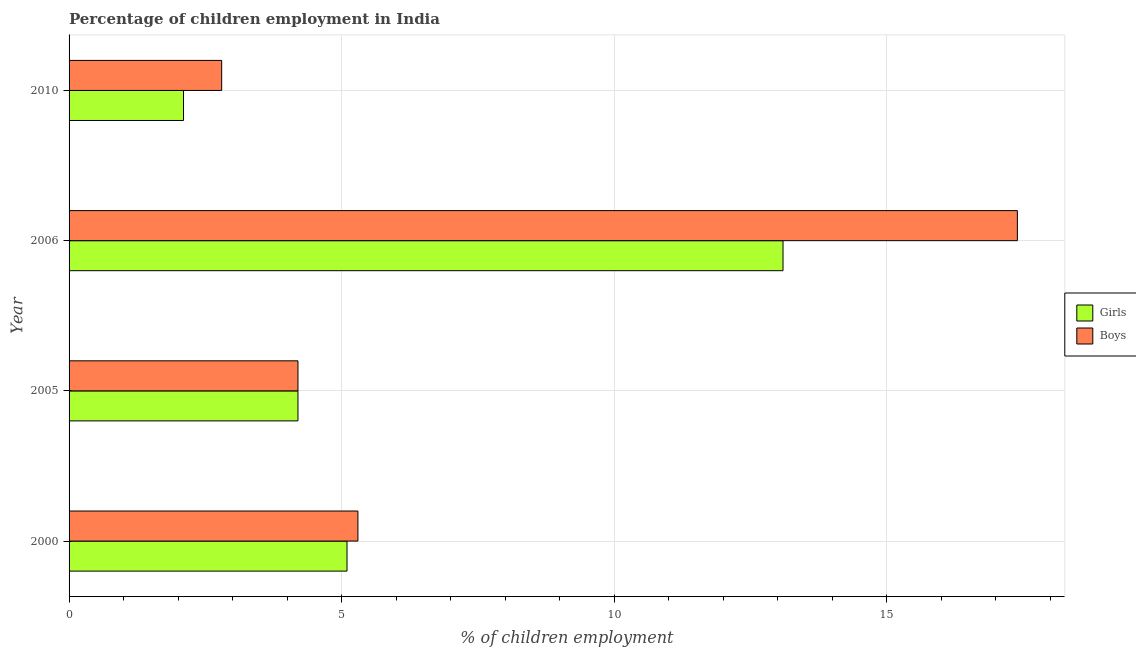How many different coloured bars are there?
Give a very brief answer. 2. How many groups of bars are there?
Offer a very short reply. 4. Are the number of bars per tick equal to the number of legend labels?
Your response must be concise. Yes. Are the number of bars on each tick of the Y-axis equal?
Provide a succinct answer. Yes. What is the label of the 4th group of bars from the top?
Offer a terse response. 2000. In how many cases, is the number of bars for a given year not equal to the number of legend labels?
Your answer should be very brief. 0. In which year was the percentage of employed boys maximum?
Offer a very short reply. 2006. In which year was the percentage of employed girls minimum?
Your response must be concise. 2010. What is the total percentage of employed boys in the graph?
Keep it short and to the point. 29.7. What is the difference between the percentage of employed girls in 2005 and the percentage of employed boys in 2006?
Your answer should be compact. -13.2. What is the average percentage of employed girls per year?
Provide a short and direct response. 6.12. In the year 2000, what is the difference between the percentage of employed boys and percentage of employed girls?
Keep it short and to the point. 0.2. In how many years, is the percentage of employed boys greater than 14 %?
Offer a very short reply. 1. What is the ratio of the percentage of employed boys in 2000 to that in 2010?
Provide a succinct answer. 1.89. What is the difference between the highest and the second highest percentage of employed girls?
Offer a terse response. 8. What is the difference between the highest and the lowest percentage of employed boys?
Offer a terse response. 14.6. In how many years, is the percentage of employed boys greater than the average percentage of employed boys taken over all years?
Offer a very short reply. 1. What does the 1st bar from the top in 2006 represents?
Ensure brevity in your answer.  Boys. What does the 2nd bar from the bottom in 2006 represents?
Keep it short and to the point. Boys. Are the values on the major ticks of X-axis written in scientific E-notation?
Make the answer very short. No. Where does the legend appear in the graph?
Your response must be concise. Center right. What is the title of the graph?
Offer a terse response. Percentage of children employment in India. Does "Investment in Transport" appear as one of the legend labels in the graph?
Keep it short and to the point. No. What is the label or title of the X-axis?
Your answer should be very brief. % of children employment. What is the % of children employment in Girls in 2000?
Keep it short and to the point. 5.1. What is the % of children employment in Boys in 2005?
Your response must be concise. 4.2. What is the % of children employment of Girls in 2006?
Provide a succinct answer. 13.1. What is the % of children employment in Boys in 2006?
Provide a short and direct response. 17.4. What is the % of children employment in Boys in 2010?
Ensure brevity in your answer.  2.8. Across all years, what is the maximum % of children employment of Boys?
Make the answer very short. 17.4. Across all years, what is the minimum % of children employment in Boys?
Ensure brevity in your answer.  2.8. What is the total % of children employment in Boys in the graph?
Your answer should be compact. 29.7. What is the difference between the % of children employment of Girls in 2000 and that in 2005?
Your answer should be compact. 0.9. What is the difference between the % of children employment of Boys in 2000 and that in 2005?
Provide a short and direct response. 1.1. What is the difference between the % of children employment of Girls in 2000 and that in 2010?
Your response must be concise. 3. What is the difference between the % of children employment of Boys in 2000 and that in 2010?
Provide a short and direct response. 2.5. What is the difference between the % of children employment of Boys in 2005 and that in 2010?
Give a very brief answer. 1.4. What is the difference between the % of children employment of Girls in 2006 and that in 2010?
Make the answer very short. 11. What is the difference between the % of children employment in Girls in 2000 and the % of children employment in Boys in 2010?
Offer a very short reply. 2.3. What is the difference between the % of children employment in Girls in 2005 and the % of children employment in Boys in 2006?
Keep it short and to the point. -13.2. What is the average % of children employment in Girls per year?
Ensure brevity in your answer.  6.12. What is the average % of children employment in Boys per year?
Keep it short and to the point. 7.42. In the year 2000, what is the difference between the % of children employment of Girls and % of children employment of Boys?
Make the answer very short. -0.2. In the year 2005, what is the difference between the % of children employment in Girls and % of children employment in Boys?
Your response must be concise. 0. In the year 2010, what is the difference between the % of children employment in Girls and % of children employment in Boys?
Keep it short and to the point. -0.7. What is the ratio of the % of children employment in Girls in 2000 to that in 2005?
Offer a very short reply. 1.21. What is the ratio of the % of children employment in Boys in 2000 to that in 2005?
Your answer should be compact. 1.26. What is the ratio of the % of children employment in Girls in 2000 to that in 2006?
Offer a terse response. 0.39. What is the ratio of the % of children employment in Boys in 2000 to that in 2006?
Provide a succinct answer. 0.3. What is the ratio of the % of children employment of Girls in 2000 to that in 2010?
Your answer should be very brief. 2.43. What is the ratio of the % of children employment in Boys in 2000 to that in 2010?
Make the answer very short. 1.89. What is the ratio of the % of children employment of Girls in 2005 to that in 2006?
Your answer should be compact. 0.32. What is the ratio of the % of children employment in Boys in 2005 to that in 2006?
Give a very brief answer. 0.24. What is the ratio of the % of children employment of Girls in 2005 to that in 2010?
Offer a very short reply. 2. What is the ratio of the % of children employment of Girls in 2006 to that in 2010?
Your response must be concise. 6.24. What is the ratio of the % of children employment of Boys in 2006 to that in 2010?
Your answer should be very brief. 6.21. What is the difference between the highest and the lowest % of children employment in Girls?
Your answer should be very brief. 11. 